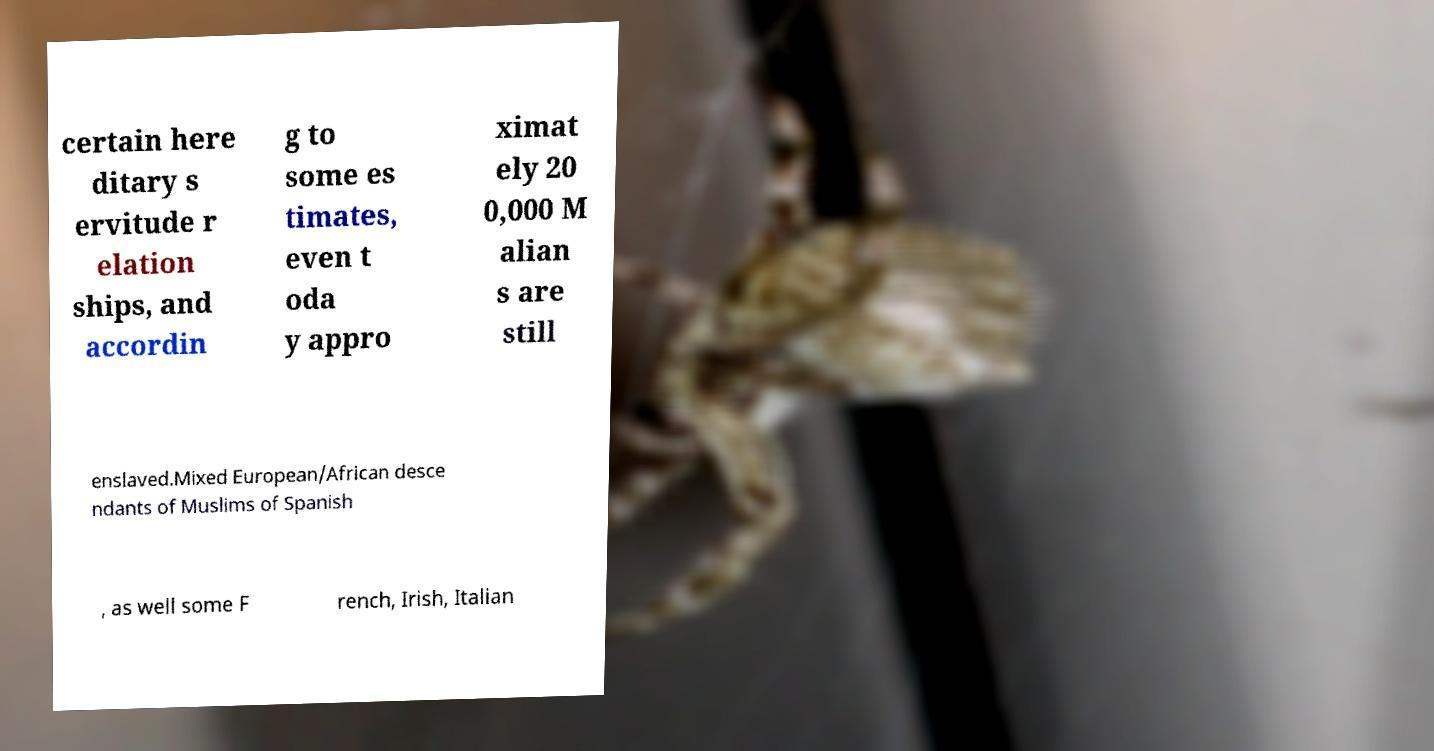Please identify and transcribe the text found in this image. certain here ditary s ervitude r elation ships, and accordin g to some es timates, even t oda y appro ximat ely 20 0,000 M alian s are still enslaved.Mixed European/African desce ndants of Muslims of Spanish , as well some F rench, Irish, Italian 